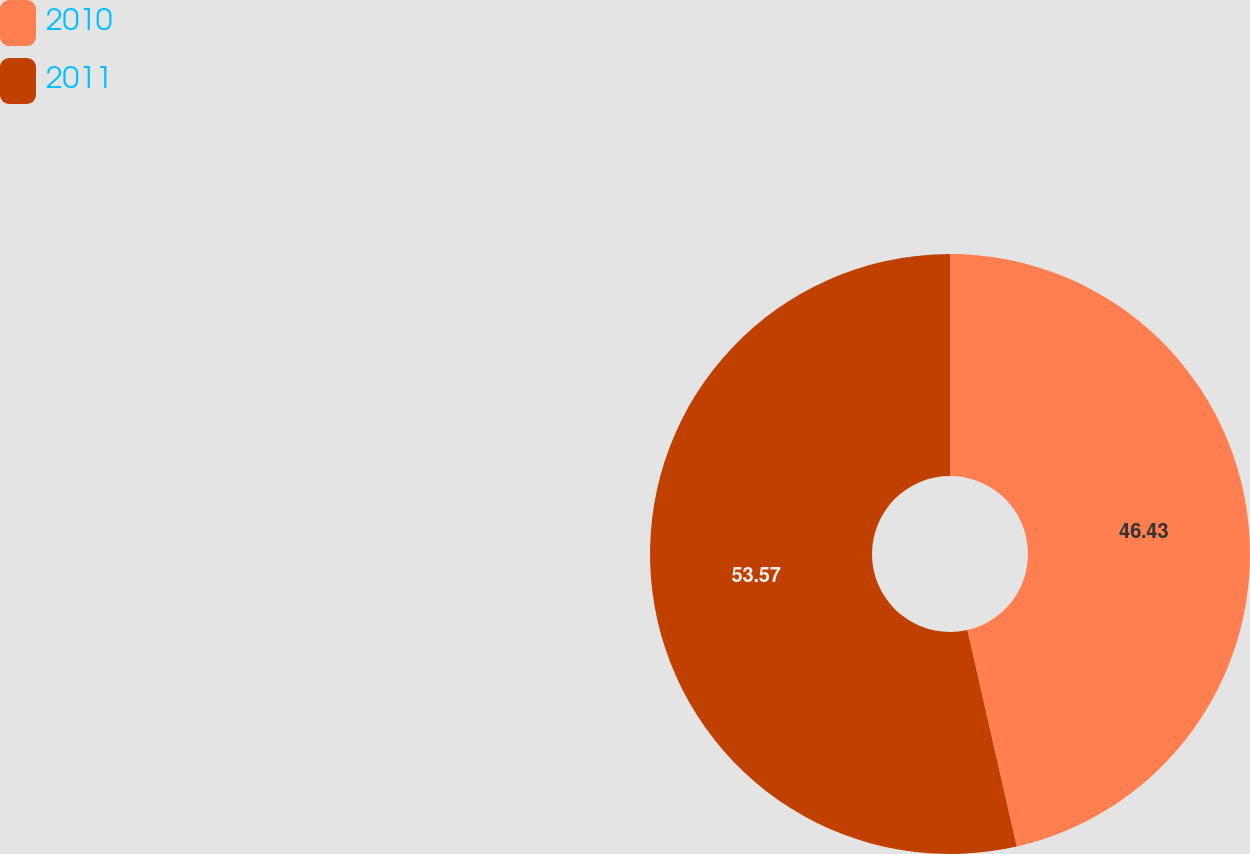<chart> <loc_0><loc_0><loc_500><loc_500><pie_chart><fcel>2010<fcel>2011<nl><fcel>46.43%<fcel>53.57%<nl></chart> 